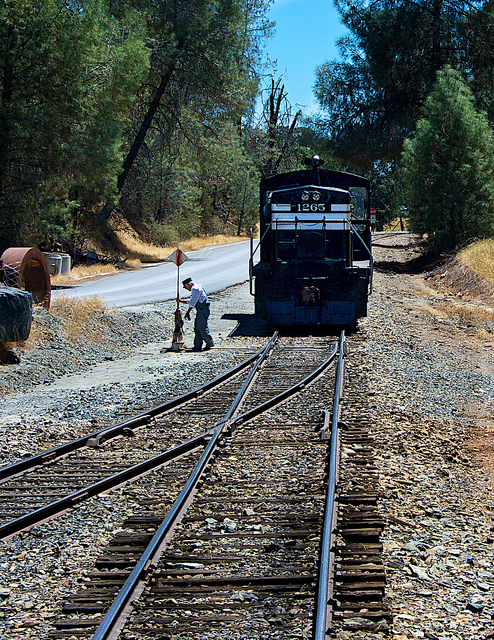What time of day does it seem to be? Judging by the shadows and the intensity of the sunlight, it seems to be midday or early afternoon when the sun is high in the sky. 